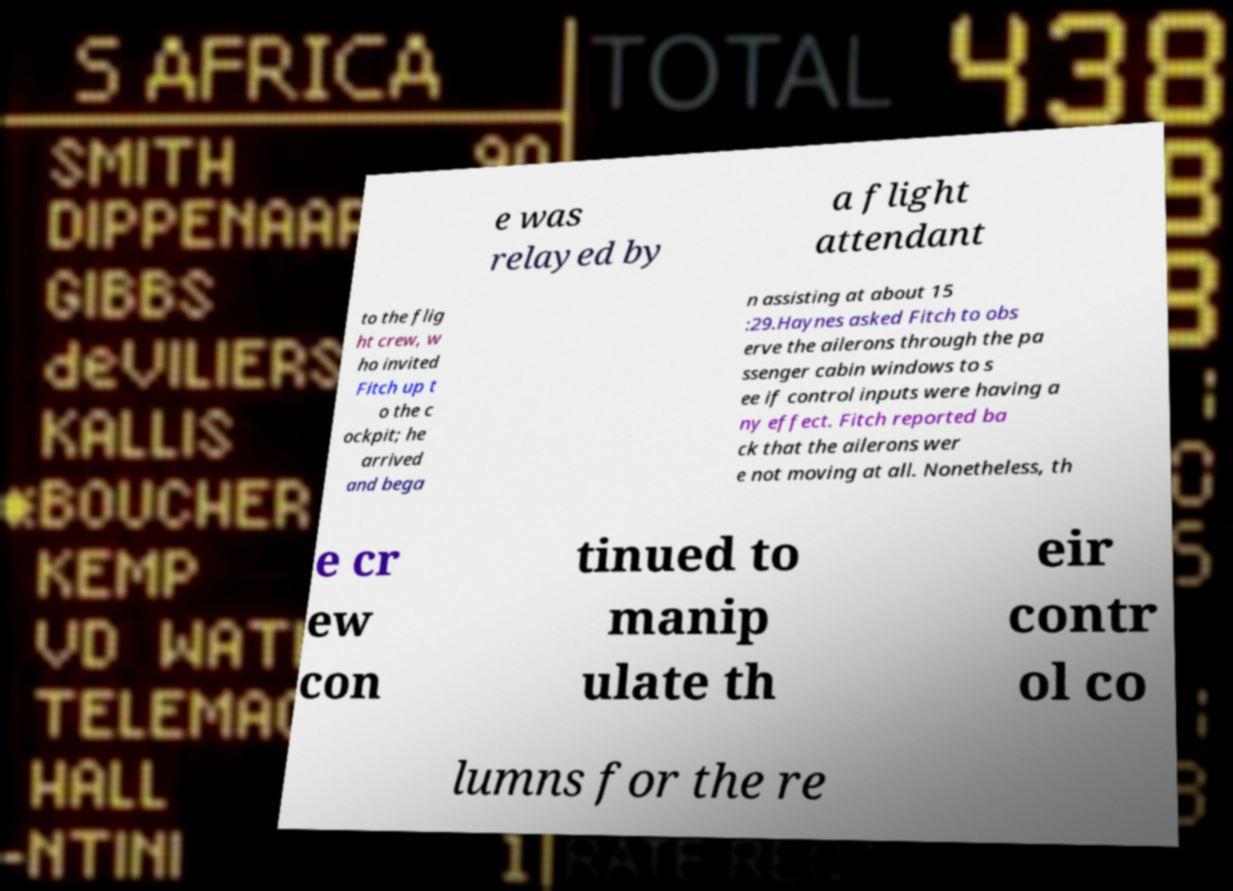Can you accurately transcribe the text from the provided image for me? e was relayed by a flight attendant to the flig ht crew, w ho invited Fitch up t o the c ockpit; he arrived and bega n assisting at about 15 :29.Haynes asked Fitch to obs erve the ailerons through the pa ssenger cabin windows to s ee if control inputs were having a ny effect. Fitch reported ba ck that the ailerons wer e not moving at all. Nonetheless, th e cr ew con tinued to manip ulate th eir contr ol co lumns for the re 